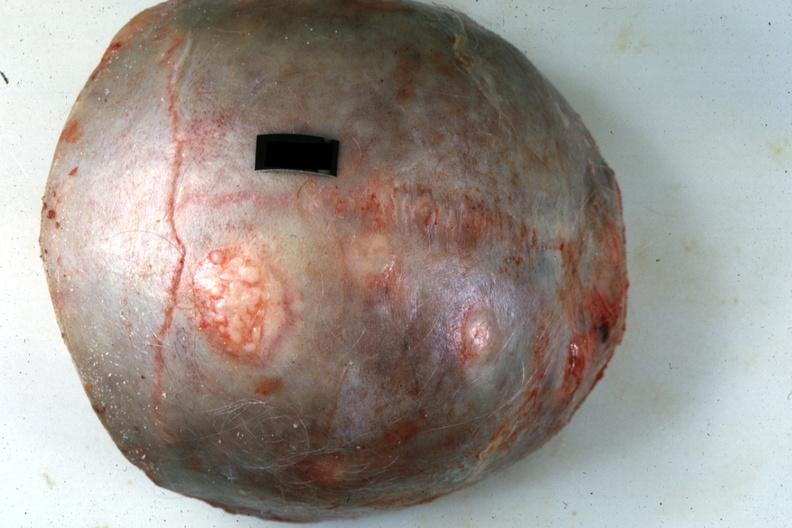what is present?
Answer the question using a single word or phrase. Bone 